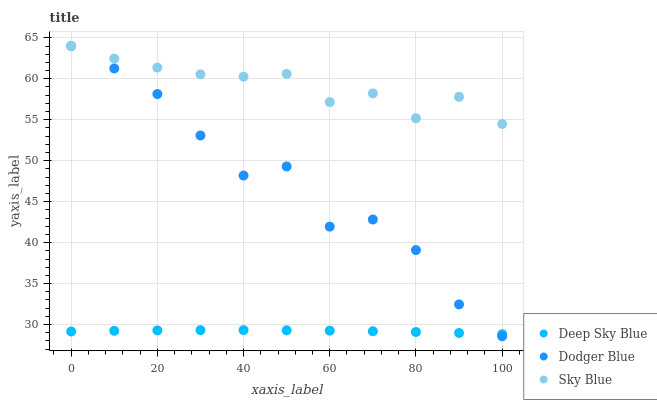Does Deep Sky Blue have the minimum area under the curve?
Answer yes or no. Yes. Does Sky Blue have the maximum area under the curve?
Answer yes or no. Yes. Does Dodger Blue have the minimum area under the curve?
Answer yes or no. No. Does Dodger Blue have the maximum area under the curve?
Answer yes or no. No. Is Deep Sky Blue the smoothest?
Answer yes or no. Yes. Is Dodger Blue the roughest?
Answer yes or no. Yes. Is Dodger Blue the smoothest?
Answer yes or no. No. Is Deep Sky Blue the roughest?
Answer yes or no. No. Does Dodger Blue have the lowest value?
Answer yes or no. Yes. Does Deep Sky Blue have the lowest value?
Answer yes or no. No. Does Dodger Blue have the highest value?
Answer yes or no. Yes. Does Deep Sky Blue have the highest value?
Answer yes or no. No. Is Deep Sky Blue less than Sky Blue?
Answer yes or no. Yes. Is Sky Blue greater than Deep Sky Blue?
Answer yes or no. Yes. Does Dodger Blue intersect Deep Sky Blue?
Answer yes or no. Yes. Is Dodger Blue less than Deep Sky Blue?
Answer yes or no. No. Is Dodger Blue greater than Deep Sky Blue?
Answer yes or no. No. Does Deep Sky Blue intersect Sky Blue?
Answer yes or no. No. 